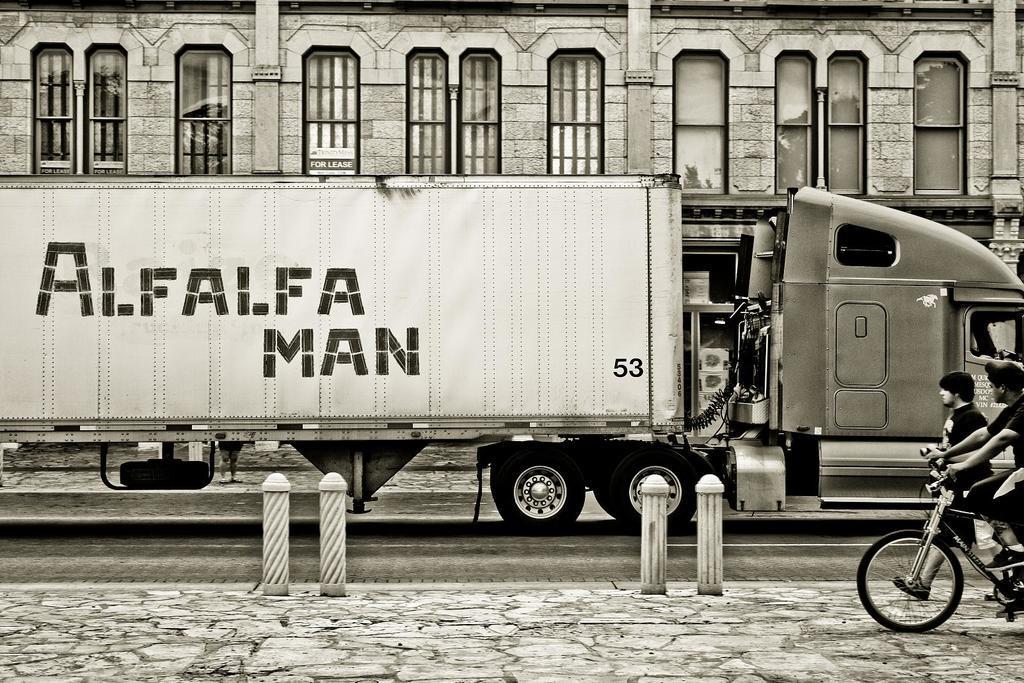Describe this image in one or two sentences. There is a truck which has something written on it and there are two persons in the right corner and there is a building in the background. 